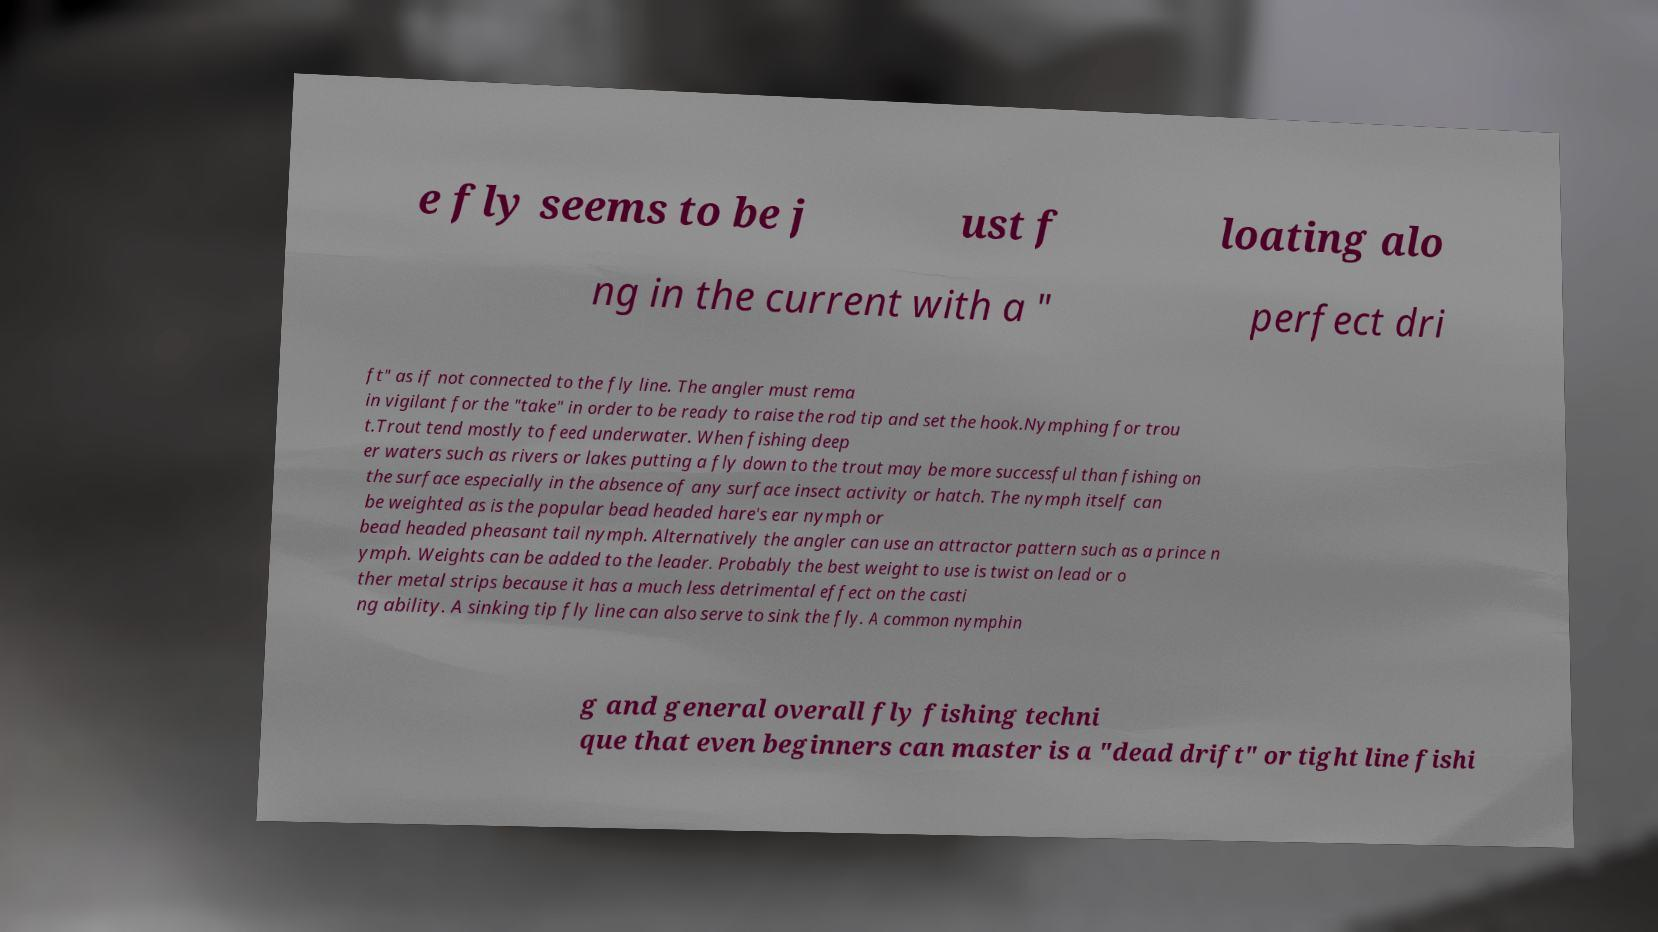For documentation purposes, I need the text within this image transcribed. Could you provide that? e fly seems to be j ust f loating alo ng in the current with a " perfect dri ft" as if not connected to the fly line. The angler must rema in vigilant for the "take" in order to be ready to raise the rod tip and set the hook.Nymphing for trou t.Trout tend mostly to feed underwater. When fishing deep er waters such as rivers or lakes putting a fly down to the trout may be more successful than fishing on the surface especially in the absence of any surface insect activity or hatch. The nymph itself can be weighted as is the popular bead headed hare's ear nymph or bead headed pheasant tail nymph. Alternatively the angler can use an attractor pattern such as a prince n ymph. Weights can be added to the leader. Probably the best weight to use is twist on lead or o ther metal strips because it has a much less detrimental effect on the casti ng ability. A sinking tip fly line can also serve to sink the fly. A common nymphin g and general overall fly fishing techni que that even beginners can master is a "dead drift" or tight line fishi 